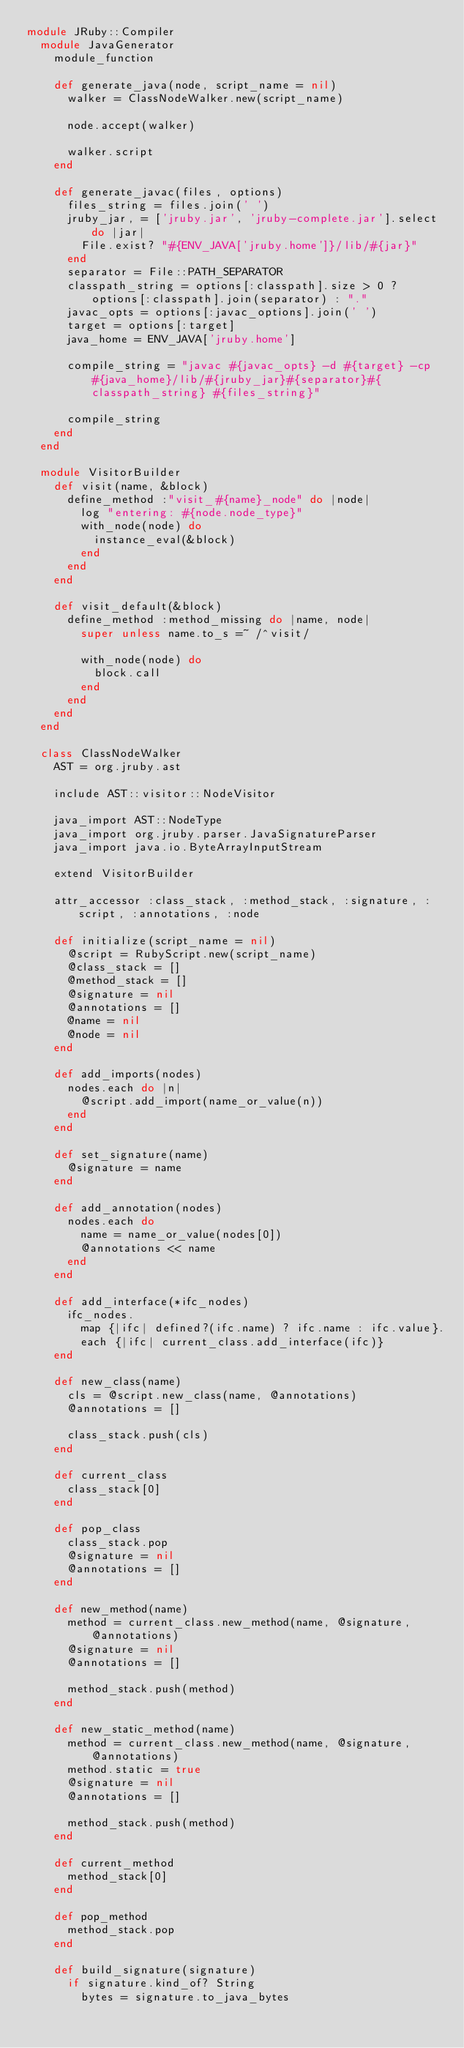Convert code to text. <code><loc_0><loc_0><loc_500><loc_500><_Ruby_>module JRuby::Compiler
  module JavaGenerator
    module_function

    def generate_java(node, script_name = nil)
      walker = ClassNodeWalker.new(script_name)

      node.accept(walker)

      walker.script
    end

    def generate_javac(files, options)
      files_string = files.join(' ')
      jruby_jar, = ['jruby.jar', 'jruby-complete.jar'].select do |jar|
        File.exist? "#{ENV_JAVA['jruby.home']}/lib/#{jar}"
      end
      separator = File::PATH_SEPARATOR
      classpath_string = options[:classpath].size > 0 ? options[:classpath].join(separator) : "."
      javac_opts = options[:javac_options].join(' ')
      target = options[:target]
      java_home = ENV_JAVA['jruby.home']

      compile_string = "javac #{javac_opts} -d #{target} -cp #{java_home}/lib/#{jruby_jar}#{separator}#{classpath_string} #{files_string}"

      compile_string
    end
  end

  module VisitorBuilder
    def visit(name, &block)
      define_method :"visit_#{name}_node" do |node|
        log "entering: #{node.node_type}"
        with_node(node) do
          instance_eval(&block)
        end
      end
    end

    def visit_default(&block)
      define_method :method_missing do |name, node|
        super unless name.to_s =~ /^visit/

        with_node(node) do
          block.call
        end
      end
    end
  end

  class ClassNodeWalker
    AST = org.jruby.ast

    include AST::visitor::NodeVisitor

    java_import AST::NodeType
    java_import org.jruby.parser.JavaSignatureParser
    java_import java.io.ByteArrayInputStream

    extend VisitorBuilder

    attr_accessor :class_stack, :method_stack, :signature, :script, :annotations, :node

    def initialize(script_name = nil)
      @script = RubyScript.new(script_name)
      @class_stack = []
      @method_stack = []
      @signature = nil
      @annotations = []
      @name = nil
      @node = nil
    end

    def add_imports(nodes)
      nodes.each do |n|
        @script.add_import(name_or_value(n))
      end
    end

    def set_signature(name)
      @signature = name
    end

    def add_annotation(nodes)
      nodes.each do
        name = name_or_value(nodes[0])
        @annotations << name
      end
    end

    def add_interface(*ifc_nodes)
      ifc_nodes.
        map {|ifc| defined?(ifc.name) ? ifc.name : ifc.value}.
        each {|ifc| current_class.add_interface(ifc)}
    end

    def new_class(name)
      cls = @script.new_class(name, @annotations)
      @annotations = []

      class_stack.push(cls)
    end

    def current_class
      class_stack[0]
    end

    def pop_class
      class_stack.pop
      @signature = nil
      @annotations = []
    end

    def new_method(name)
      method = current_class.new_method(name, @signature, @annotations)
      @signature = nil
      @annotations = []

      method_stack.push(method)
    end

    def new_static_method(name)
      method = current_class.new_method(name, @signature, @annotations)
      method.static = true
      @signature = nil
      @annotations = []

      method_stack.push(method)
    end

    def current_method
      method_stack[0]
    end

    def pop_method
      method_stack.pop
    end

    def build_signature(signature)
      if signature.kind_of? String
        bytes = signature.to_java_bytes</code> 